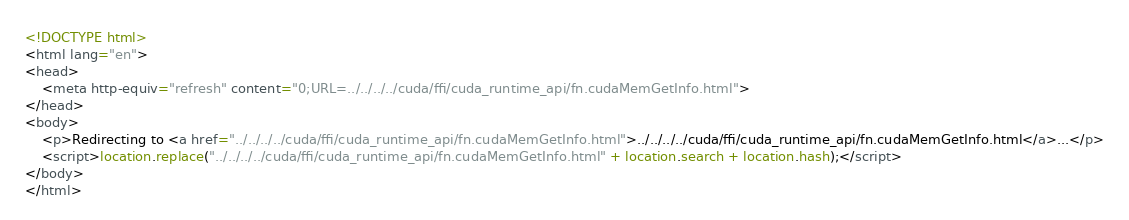<code> <loc_0><loc_0><loc_500><loc_500><_HTML_><!DOCTYPE html>
<html lang="en">
<head>
    <meta http-equiv="refresh" content="0;URL=../../../../cuda/ffi/cuda_runtime_api/fn.cudaMemGetInfo.html">
</head>
<body>
    <p>Redirecting to <a href="../../../../cuda/ffi/cuda_runtime_api/fn.cudaMemGetInfo.html">../../../../cuda/ffi/cuda_runtime_api/fn.cudaMemGetInfo.html</a>...</p>
    <script>location.replace("../../../../cuda/ffi/cuda_runtime_api/fn.cudaMemGetInfo.html" + location.search + location.hash);</script>
</body>
</html></code> 